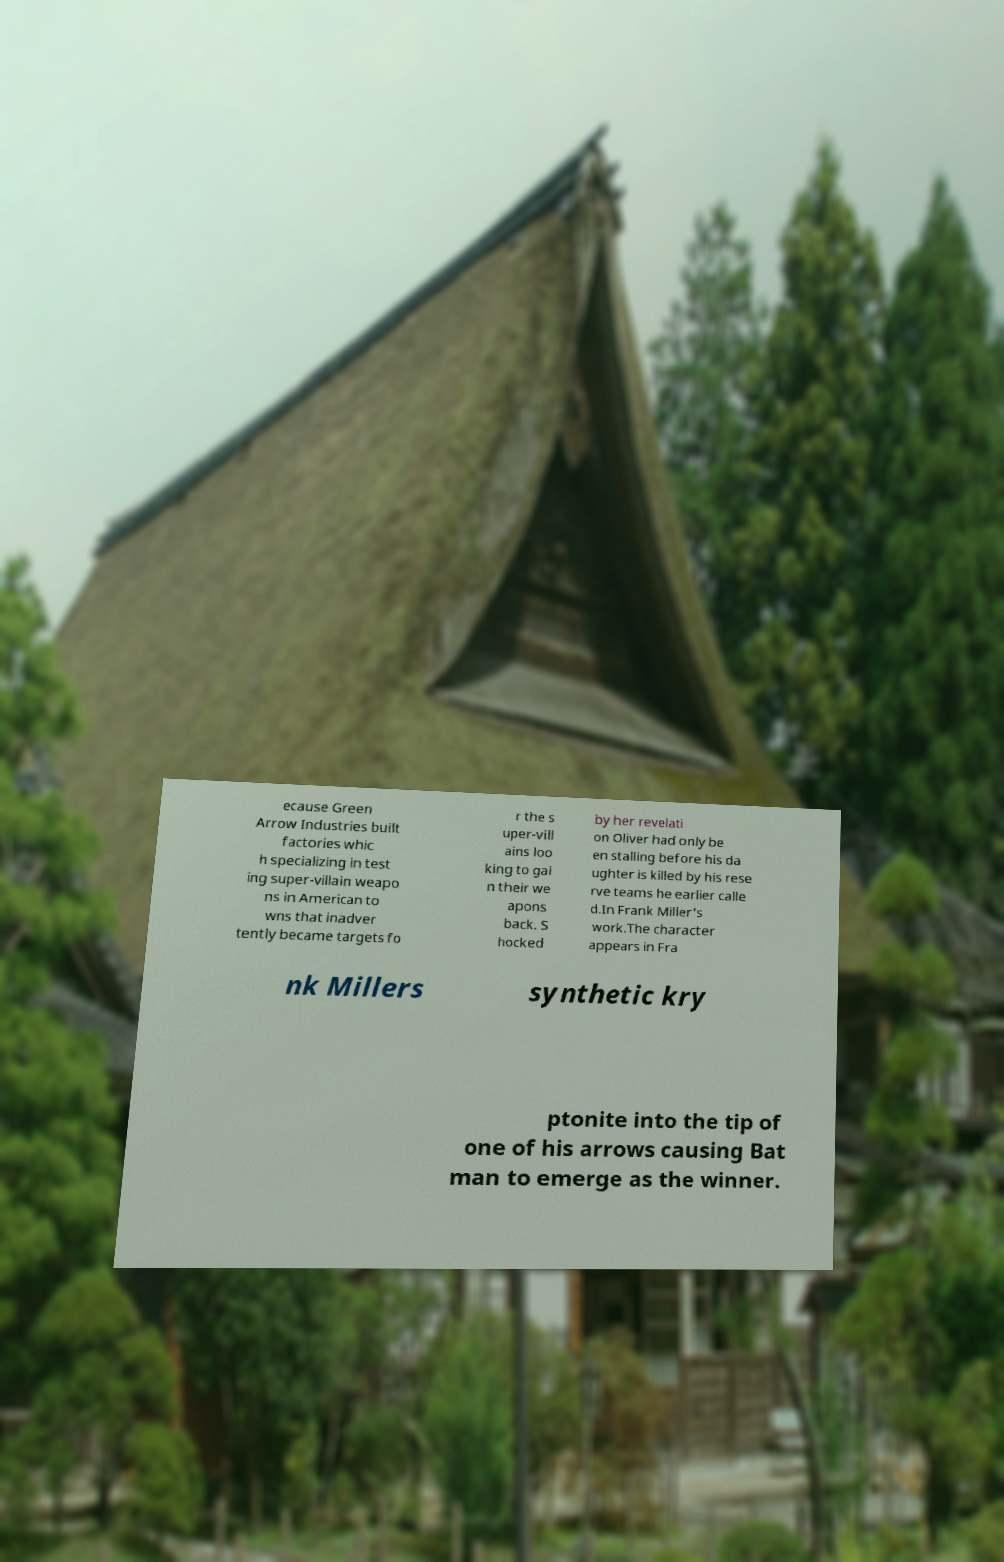Can you accurately transcribe the text from the provided image for me? ecause Green Arrow Industries built factories whic h specializing in test ing super-villain weapo ns in American to wns that inadver tently became targets fo r the s uper-vill ains loo king to gai n their we apons back. S hocked by her revelati on Oliver had only be en stalling before his da ughter is killed by his rese rve teams he earlier calle d.In Frank Miller's work.The character appears in Fra nk Millers synthetic kry ptonite into the tip of one of his arrows causing Bat man to emerge as the winner. 